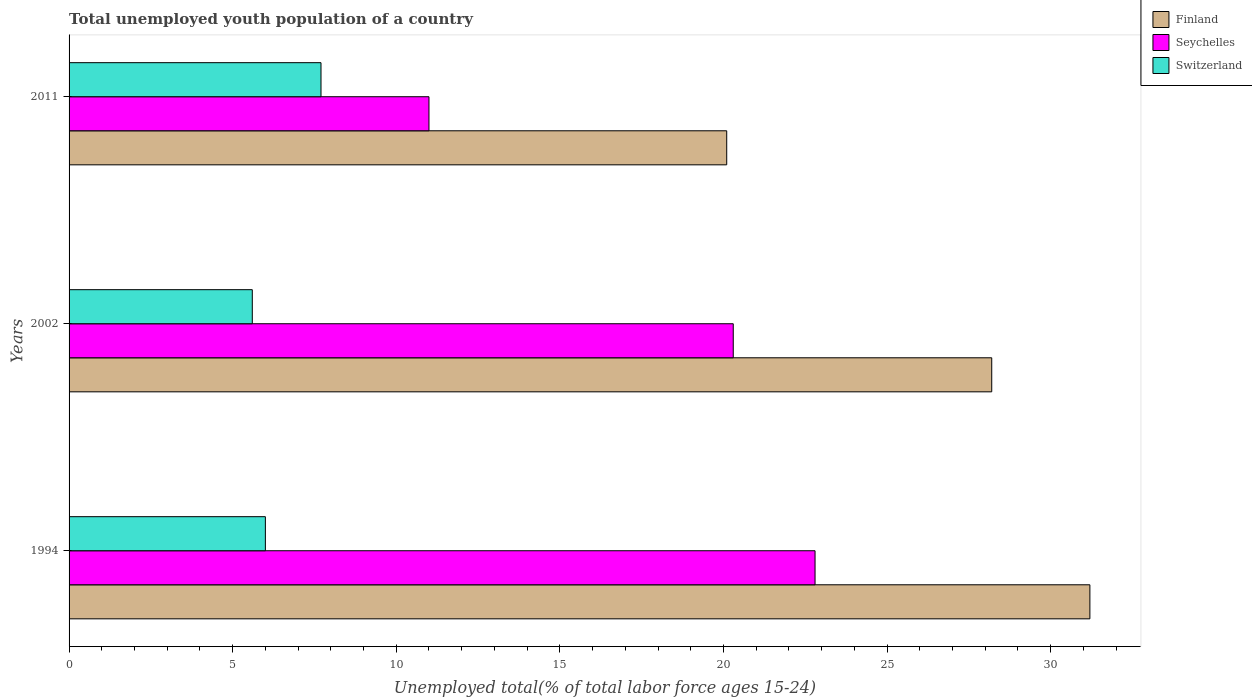Are the number of bars per tick equal to the number of legend labels?
Your answer should be very brief. Yes. What is the label of the 2nd group of bars from the top?
Provide a succinct answer. 2002. In how many cases, is the number of bars for a given year not equal to the number of legend labels?
Your answer should be very brief. 0. What is the percentage of total unemployed youth population of a country in Switzerland in 2011?
Your response must be concise. 7.7. Across all years, what is the maximum percentage of total unemployed youth population of a country in Switzerland?
Keep it short and to the point. 7.7. Across all years, what is the minimum percentage of total unemployed youth population of a country in Seychelles?
Make the answer very short. 11. What is the total percentage of total unemployed youth population of a country in Finland in the graph?
Give a very brief answer. 79.5. What is the difference between the percentage of total unemployed youth population of a country in Finland in 2002 and that in 2011?
Provide a succinct answer. 8.1. What is the difference between the percentage of total unemployed youth population of a country in Seychelles in 1994 and the percentage of total unemployed youth population of a country in Switzerland in 2011?
Make the answer very short. 15.1. What is the average percentage of total unemployed youth population of a country in Finland per year?
Offer a very short reply. 26.5. In the year 1994, what is the difference between the percentage of total unemployed youth population of a country in Seychelles and percentage of total unemployed youth population of a country in Switzerland?
Keep it short and to the point. 16.8. What is the ratio of the percentage of total unemployed youth population of a country in Finland in 2002 to that in 2011?
Your answer should be very brief. 1.4. What is the difference between the highest and the second highest percentage of total unemployed youth population of a country in Switzerland?
Make the answer very short. 1.7. What is the difference between the highest and the lowest percentage of total unemployed youth population of a country in Finland?
Offer a terse response. 11.1. In how many years, is the percentage of total unemployed youth population of a country in Switzerland greater than the average percentage of total unemployed youth population of a country in Switzerland taken over all years?
Your answer should be very brief. 1. Is the sum of the percentage of total unemployed youth population of a country in Switzerland in 2002 and 2011 greater than the maximum percentage of total unemployed youth population of a country in Finland across all years?
Give a very brief answer. No. What does the 1st bar from the top in 2002 represents?
Make the answer very short. Switzerland. Is it the case that in every year, the sum of the percentage of total unemployed youth population of a country in Seychelles and percentage of total unemployed youth population of a country in Finland is greater than the percentage of total unemployed youth population of a country in Switzerland?
Make the answer very short. Yes. How many bars are there?
Your response must be concise. 9. Are all the bars in the graph horizontal?
Your answer should be very brief. Yes. What is the difference between two consecutive major ticks on the X-axis?
Provide a short and direct response. 5. Are the values on the major ticks of X-axis written in scientific E-notation?
Your answer should be very brief. No. Where does the legend appear in the graph?
Make the answer very short. Top right. How are the legend labels stacked?
Offer a terse response. Vertical. What is the title of the graph?
Your answer should be compact. Total unemployed youth population of a country. Does "Sudan" appear as one of the legend labels in the graph?
Give a very brief answer. No. What is the label or title of the X-axis?
Offer a terse response. Unemployed total(% of total labor force ages 15-24). What is the label or title of the Y-axis?
Keep it short and to the point. Years. What is the Unemployed total(% of total labor force ages 15-24) of Finland in 1994?
Ensure brevity in your answer.  31.2. What is the Unemployed total(% of total labor force ages 15-24) in Seychelles in 1994?
Your answer should be very brief. 22.8. What is the Unemployed total(% of total labor force ages 15-24) in Finland in 2002?
Your answer should be very brief. 28.2. What is the Unemployed total(% of total labor force ages 15-24) of Seychelles in 2002?
Ensure brevity in your answer.  20.3. What is the Unemployed total(% of total labor force ages 15-24) in Switzerland in 2002?
Give a very brief answer. 5.6. What is the Unemployed total(% of total labor force ages 15-24) in Finland in 2011?
Your answer should be very brief. 20.1. What is the Unemployed total(% of total labor force ages 15-24) of Switzerland in 2011?
Provide a short and direct response. 7.7. Across all years, what is the maximum Unemployed total(% of total labor force ages 15-24) of Finland?
Offer a terse response. 31.2. Across all years, what is the maximum Unemployed total(% of total labor force ages 15-24) of Seychelles?
Offer a very short reply. 22.8. Across all years, what is the maximum Unemployed total(% of total labor force ages 15-24) of Switzerland?
Give a very brief answer. 7.7. Across all years, what is the minimum Unemployed total(% of total labor force ages 15-24) of Finland?
Make the answer very short. 20.1. Across all years, what is the minimum Unemployed total(% of total labor force ages 15-24) of Switzerland?
Make the answer very short. 5.6. What is the total Unemployed total(% of total labor force ages 15-24) of Finland in the graph?
Provide a succinct answer. 79.5. What is the total Unemployed total(% of total labor force ages 15-24) in Seychelles in the graph?
Give a very brief answer. 54.1. What is the total Unemployed total(% of total labor force ages 15-24) of Switzerland in the graph?
Provide a short and direct response. 19.3. What is the difference between the Unemployed total(% of total labor force ages 15-24) of Seychelles in 1994 and that in 2002?
Give a very brief answer. 2.5. What is the difference between the Unemployed total(% of total labor force ages 15-24) of Finland in 1994 and that in 2011?
Your answer should be very brief. 11.1. What is the difference between the Unemployed total(% of total labor force ages 15-24) in Seychelles in 1994 and that in 2011?
Ensure brevity in your answer.  11.8. What is the difference between the Unemployed total(% of total labor force ages 15-24) in Finland in 2002 and that in 2011?
Keep it short and to the point. 8.1. What is the difference between the Unemployed total(% of total labor force ages 15-24) in Seychelles in 2002 and that in 2011?
Keep it short and to the point. 9.3. What is the difference between the Unemployed total(% of total labor force ages 15-24) in Finland in 1994 and the Unemployed total(% of total labor force ages 15-24) in Switzerland in 2002?
Offer a very short reply. 25.6. What is the difference between the Unemployed total(% of total labor force ages 15-24) in Finland in 1994 and the Unemployed total(% of total labor force ages 15-24) in Seychelles in 2011?
Offer a terse response. 20.2. What is the difference between the Unemployed total(% of total labor force ages 15-24) in Finland in 1994 and the Unemployed total(% of total labor force ages 15-24) in Switzerland in 2011?
Your answer should be compact. 23.5. What is the difference between the Unemployed total(% of total labor force ages 15-24) in Finland in 2002 and the Unemployed total(% of total labor force ages 15-24) in Seychelles in 2011?
Provide a succinct answer. 17.2. What is the difference between the Unemployed total(% of total labor force ages 15-24) of Finland in 2002 and the Unemployed total(% of total labor force ages 15-24) of Switzerland in 2011?
Offer a very short reply. 20.5. What is the difference between the Unemployed total(% of total labor force ages 15-24) in Seychelles in 2002 and the Unemployed total(% of total labor force ages 15-24) in Switzerland in 2011?
Offer a very short reply. 12.6. What is the average Unemployed total(% of total labor force ages 15-24) of Seychelles per year?
Keep it short and to the point. 18.03. What is the average Unemployed total(% of total labor force ages 15-24) of Switzerland per year?
Your answer should be compact. 6.43. In the year 1994, what is the difference between the Unemployed total(% of total labor force ages 15-24) in Finland and Unemployed total(% of total labor force ages 15-24) in Seychelles?
Your answer should be very brief. 8.4. In the year 1994, what is the difference between the Unemployed total(% of total labor force ages 15-24) in Finland and Unemployed total(% of total labor force ages 15-24) in Switzerland?
Make the answer very short. 25.2. In the year 1994, what is the difference between the Unemployed total(% of total labor force ages 15-24) in Seychelles and Unemployed total(% of total labor force ages 15-24) in Switzerland?
Keep it short and to the point. 16.8. In the year 2002, what is the difference between the Unemployed total(% of total labor force ages 15-24) of Finland and Unemployed total(% of total labor force ages 15-24) of Seychelles?
Provide a succinct answer. 7.9. In the year 2002, what is the difference between the Unemployed total(% of total labor force ages 15-24) of Finland and Unemployed total(% of total labor force ages 15-24) of Switzerland?
Offer a terse response. 22.6. In the year 2002, what is the difference between the Unemployed total(% of total labor force ages 15-24) of Seychelles and Unemployed total(% of total labor force ages 15-24) of Switzerland?
Your response must be concise. 14.7. In the year 2011, what is the difference between the Unemployed total(% of total labor force ages 15-24) in Finland and Unemployed total(% of total labor force ages 15-24) in Seychelles?
Provide a short and direct response. 9.1. In the year 2011, what is the difference between the Unemployed total(% of total labor force ages 15-24) of Finland and Unemployed total(% of total labor force ages 15-24) of Switzerland?
Offer a very short reply. 12.4. In the year 2011, what is the difference between the Unemployed total(% of total labor force ages 15-24) of Seychelles and Unemployed total(% of total labor force ages 15-24) of Switzerland?
Make the answer very short. 3.3. What is the ratio of the Unemployed total(% of total labor force ages 15-24) of Finland in 1994 to that in 2002?
Give a very brief answer. 1.11. What is the ratio of the Unemployed total(% of total labor force ages 15-24) of Seychelles in 1994 to that in 2002?
Ensure brevity in your answer.  1.12. What is the ratio of the Unemployed total(% of total labor force ages 15-24) in Switzerland in 1994 to that in 2002?
Provide a succinct answer. 1.07. What is the ratio of the Unemployed total(% of total labor force ages 15-24) in Finland in 1994 to that in 2011?
Make the answer very short. 1.55. What is the ratio of the Unemployed total(% of total labor force ages 15-24) in Seychelles in 1994 to that in 2011?
Keep it short and to the point. 2.07. What is the ratio of the Unemployed total(% of total labor force ages 15-24) of Switzerland in 1994 to that in 2011?
Your answer should be very brief. 0.78. What is the ratio of the Unemployed total(% of total labor force ages 15-24) in Finland in 2002 to that in 2011?
Provide a succinct answer. 1.4. What is the ratio of the Unemployed total(% of total labor force ages 15-24) of Seychelles in 2002 to that in 2011?
Provide a succinct answer. 1.85. What is the ratio of the Unemployed total(% of total labor force ages 15-24) of Switzerland in 2002 to that in 2011?
Your answer should be very brief. 0.73. What is the difference between the highest and the second highest Unemployed total(% of total labor force ages 15-24) in Finland?
Give a very brief answer. 3. What is the difference between the highest and the second highest Unemployed total(% of total labor force ages 15-24) in Seychelles?
Your answer should be compact. 2.5. What is the difference between the highest and the second highest Unemployed total(% of total labor force ages 15-24) of Switzerland?
Offer a terse response. 1.7. What is the difference between the highest and the lowest Unemployed total(% of total labor force ages 15-24) of Switzerland?
Ensure brevity in your answer.  2.1. 